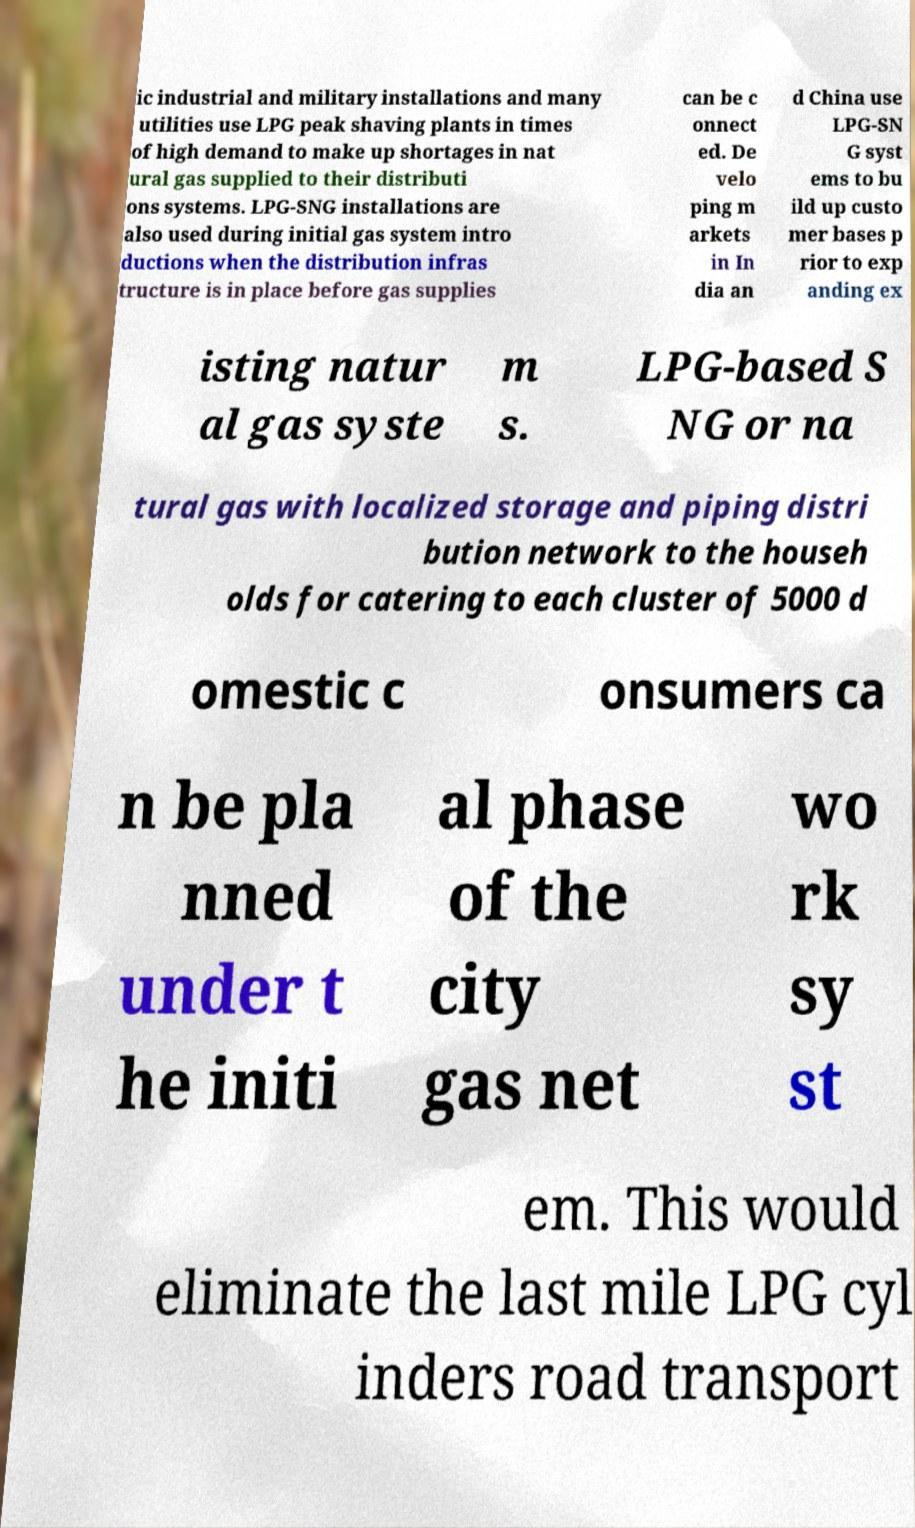There's text embedded in this image that I need extracted. Can you transcribe it verbatim? ic industrial and military installations and many utilities use LPG peak shaving plants in times of high demand to make up shortages in nat ural gas supplied to their distributi ons systems. LPG-SNG installations are also used during initial gas system intro ductions when the distribution infras tructure is in place before gas supplies can be c onnect ed. De velo ping m arkets in In dia an d China use LPG-SN G syst ems to bu ild up custo mer bases p rior to exp anding ex isting natur al gas syste m s. LPG-based S NG or na tural gas with localized storage and piping distri bution network to the househ olds for catering to each cluster of 5000 d omestic c onsumers ca n be pla nned under t he initi al phase of the city gas net wo rk sy st em. This would eliminate the last mile LPG cyl inders road transport 